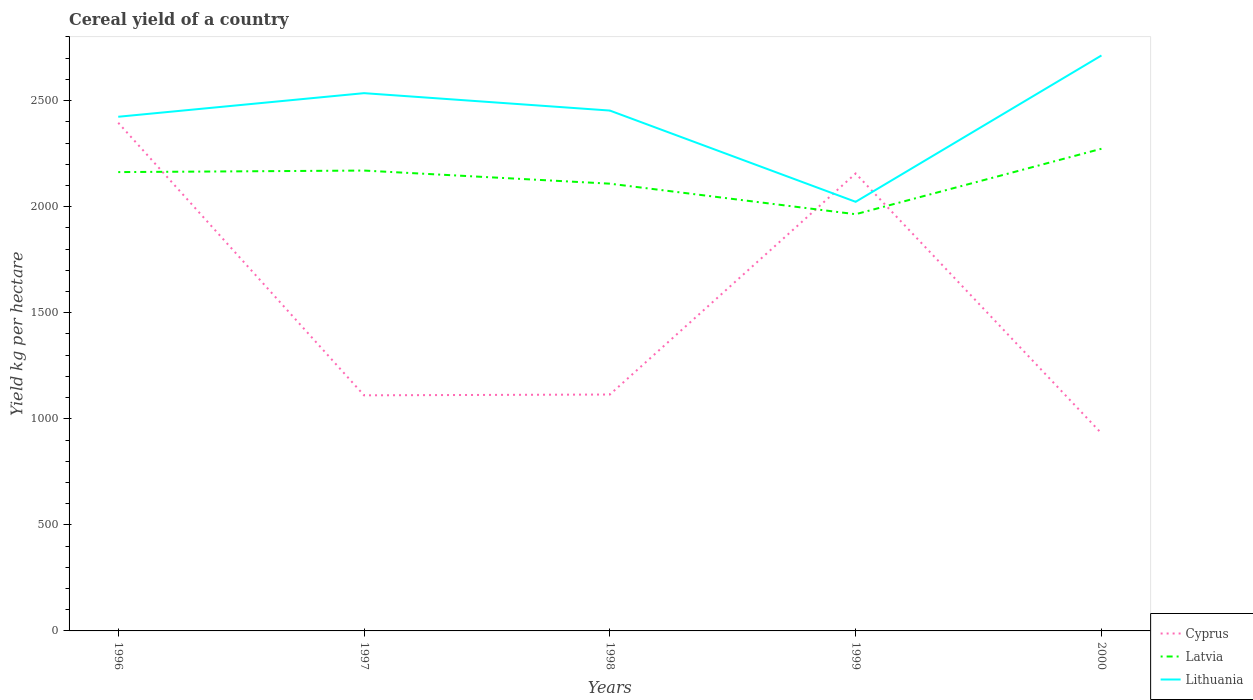Across all years, what is the maximum total cereal yield in Lithuania?
Provide a succinct answer. 2022.91. In which year was the total cereal yield in Lithuania maximum?
Provide a succinct answer. 1999. What is the total total cereal yield in Latvia in the graph?
Make the answer very short. 198.57. What is the difference between the highest and the second highest total cereal yield in Cyprus?
Offer a very short reply. 1464.06. What is the difference between the highest and the lowest total cereal yield in Cyprus?
Give a very brief answer. 2. Is the total cereal yield in Lithuania strictly greater than the total cereal yield in Cyprus over the years?
Provide a short and direct response. No. Does the graph contain grids?
Your response must be concise. No. How many legend labels are there?
Offer a very short reply. 3. What is the title of the graph?
Your response must be concise. Cereal yield of a country. Does "Hungary" appear as one of the legend labels in the graph?
Your answer should be compact. No. What is the label or title of the Y-axis?
Your answer should be compact. Yield kg per hectare. What is the Yield kg per hectare of Cyprus in 1996?
Your answer should be very brief. 2395.49. What is the Yield kg per hectare in Latvia in 1996?
Your answer should be very brief. 2162.99. What is the Yield kg per hectare of Lithuania in 1996?
Keep it short and to the point. 2423.86. What is the Yield kg per hectare in Cyprus in 1997?
Offer a terse response. 1110.65. What is the Yield kg per hectare in Latvia in 1997?
Keep it short and to the point. 2170.23. What is the Yield kg per hectare in Lithuania in 1997?
Make the answer very short. 2535.12. What is the Yield kg per hectare in Cyprus in 1998?
Ensure brevity in your answer.  1114.4. What is the Yield kg per hectare of Latvia in 1998?
Give a very brief answer. 2108.4. What is the Yield kg per hectare of Lithuania in 1998?
Give a very brief answer. 2453.09. What is the Yield kg per hectare in Cyprus in 1999?
Your response must be concise. 2156.43. What is the Yield kg per hectare in Latvia in 1999?
Provide a succinct answer. 1964.42. What is the Yield kg per hectare in Lithuania in 1999?
Make the answer very short. 2022.91. What is the Yield kg per hectare of Cyprus in 2000?
Your answer should be compact. 931.43. What is the Yield kg per hectare in Latvia in 2000?
Your response must be concise. 2273.05. What is the Yield kg per hectare in Lithuania in 2000?
Provide a succinct answer. 2712.78. Across all years, what is the maximum Yield kg per hectare in Cyprus?
Offer a very short reply. 2395.49. Across all years, what is the maximum Yield kg per hectare in Latvia?
Offer a very short reply. 2273.05. Across all years, what is the maximum Yield kg per hectare in Lithuania?
Your answer should be compact. 2712.78. Across all years, what is the minimum Yield kg per hectare in Cyprus?
Your answer should be compact. 931.43. Across all years, what is the minimum Yield kg per hectare in Latvia?
Your answer should be very brief. 1964.42. Across all years, what is the minimum Yield kg per hectare in Lithuania?
Provide a succinct answer. 2022.91. What is the total Yield kg per hectare in Cyprus in the graph?
Ensure brevity in your answer.  7708.4. What is the total Yield kg per hectare in Latvia in the graph?
Provide a short and direct response. 1.07e+04. What is the total Yield kg per hectare in Lithuania in the graph?
Your answer should be compact. 1.21e+04. What is the difference between the Yield kg per hectare of Cyprus in 1996 and that in 1997?
Offer a very short reply. 1284.84. What is the difference between the Yield kg per hectare in Latvia in 1996 and that in 1997?
Give a very brief answer. -7.24. What is the difference between the Yield kg per hectare of Lithuania in 1996 and that in 1997?
Offer a very short reply. -111.26. What is the difference between the Yield kg per hectare of Cyprus in 1996 and that in 1998?
Make the answer very short. 1281.09. What is the difference between the Yield kg per hectare of Latvia in 1996 and that in 1998?
Your answer should be very brief. 54.59. What is the difference between the Yield kg per hectare in Lithuania in 1996 and that in 1998?
Ensure brevity in your answer.  -29.23. What is the difference between the Yield kg per hectare in Cyprus in 1996 and that in 1999?
Ensure brevity in your answer.  239.06. What is the difference between the Yield kg per hectare in Latvia in 1996 and that in 1999?
Your answer should be compact. 198.57. What is the difference between the Yield kg per hectare of Lithuania in 1996 and that in 1999?
Your answer should be very brief. 400.95. What is the difference between the Yield kg per hectare of Cyprus in 1996 and that in 2000?
Offer a very short reply. 1464.06. What is the difference between the Yield kg per hectare in Latvia in 1996 and that in 2000?
Provide a short and direct response. -110.06. What is the difference between the Yield kg per hectare in Lithuania in 1996 and that in 2000?
Keep it short and to the point. -288.93. What is the difference between the Yield kg per hectare in Cyprus in 1997 and that in 1998?
Your response must be concise. -3.76. What is the difference between the Yield kg per hectare of Latvia in 1997 and that in 1998?
Offer a very short reply. 61.83. What is the difference between the Yield kg per hectare in Lithuania in 1997 and that in 1998?
Your response must be concise. 82.03. What is the difference between the Yield kg per hectare in Cyprus in 1997 and that in 1999?
Ensure brevity in your answer.  -1045.78. What is the difference between the Yield kg per hectare of Latvia in 1997 and that in 1999?
Offer a terse response. 205.81. What is the difference between the Yield kg per hectare of Lithuania in 1997 and that in 1999?
Provide a short and direct response. 512.21. What is the difference between the Yield kg per hectare of Cyprus in 1997 and that in 2000?
Your response must be concise. 179.22. What is the difference between the Yield kg per hectare in Latvia in 1997 and that in 2000?
Provide a succinct answer. -102.82. What is the difference between the Yield kg per hectare in Lithuania in 1997 and that in 2000?
Provide a succinct answer. -177.66. What is the difference between the Yield kg per hectare of Cyprus in 1998 and that in 1999?
Provide a short and direct response. -1042.03. What is the difference between the Yield kg per hectare of Latvia in 1998 and that in 1999?
Make the answer very short. 143.98. What is the difference between the Yield kg per hectare in Lithuania in 1998 and that in 1999?
Make the answer very short. 430.18. What is the difference between the Yield kg per hectare of Cyprus in 1998 and that in 2000?
Your answer should be compact. 182.97. What is the difference between the Yield kg per hectare of Latvia in 1998 and that in 2000?
Give a very brief answer. -164.65. What is the difference between the Yield kg per hectare of Lithuania in 1998 and that in 2000?
Offer a very short reply. -259.69. What is the difference between the Yield kg per hectare of Cyprus in 1999 and that in 2000?
Offer a very short reply. 1225. What is the difference between the Yield kg per hectare in Latvia in 1999 and that in 2000?
Provide a succinct answer. -308.63. What is the difference between the Yield kg per hectare of Lithuania in 1999 and that in 2000?
Your response must be concise. -689.87. What is the difference between the Yield kg per hectare of Cyprus in 1996 and the Yield kg per hectare of Latvia in 1997?
Your answer should be compact. 225.26. What is the difference between the Yield kg per hectare in Cyprus in 1996 and the Yield kg per hectare in Lithuania in 1997?
Make the answer very short. -139.63. What is the difference between the Yield kg per hectare of Latvia in 1996 and the Yield kg per hectare of Lithuania in 1997?
Offer a terse response. -372.13. What is the difference between the Yield kg per hectare of Cyprus in 1996 and the Yield kg per hectare of Latvia in 1998?
Keep it short and to the point. 287.09. What is the difference between the Yield kg per hectare in Cyprus in 1996 and the Yield kg per hectare in Lithuania in 1998?
Provide a short and direct response. -57.61. What is the difference between the Yield kg per hectare in Latvia in 1996 and the Yield kg per hectare in Lithuania in 1998?
Give a very brief answer. -290.1. What is the difference between the Yield kg per hectare in Cyprus in 1996 and the Yield kg per hectare in Latvia in 1999?
Keep it short and to the point. 431.07. What is the difference between the Yield kg per hectare in Cyprus in 1996 and the Yield kg per hectare in Lithuania in 1999?
Provide a succinct answer. 372.58. What is the difference between the Yield kg per hectare in Latvia in 1996 and the Yield kg per hectare in Lithuania in 1999?
Keep it short and to the point. 140.08. What is the difference between the Yield kg per hectare of Cyprus in 1996 and the Yield kg per hectare of Latvia in 2000?
Provide a succinct answer. 122.44. What is the difference between the Yield kg per hectare of Cyprus in 1996 and the Yield kg per hectare of Lithuania in 2000?
Ensure brevity in your answer.  -317.3. What is the difference between the Yield kg per hectare in Latvia in 1996 and the Yield kg per hectare in Lithuania in 2000?
Give a very brief answer. -549.79. What is the difference between the Yield kg per hectare of Cyprus in 1997 and the Yield kg per hectare of Latvia in 1998?
Offer a terse response. -997.75. What is the difference between the Yield kg per hectare of Cyprus in 1997 and the Yield kg per hectare of Lithuania in 1998?
Make the answer very short. -1342.45. What is the difference between the Yield kg per hectare in Latvia in 1997 and the Yield kg per hectare in Lithuania in 1998?
Keep it short and to the point. -282.86. What is the difference between the Yield kg per hectare in Cyprus in 1997 and the Yield kg per hectare in Latvia in 1999?
Make the answer very short. -853.77. What is the difference between the Yield kg per hectare in Cyprus in 1997 and the Yield kg per hectare in Lithuania in 1999?
Provide a succinct answer. -912.26. What is the difference between the Yield kg per hectare of Latvia in 1997 and the Yield kg per hectare of Lithuania in 1999?
Keep it short and to the point. 147.32. What is the difference between the Yield kg per hectare of Cyprus in 1997 and the Yield kg per hectare of Latvia in 2000?
Provide a short and direct response. -1162.4. What is the difference between the Yield kg per hectare of Cyprus in 1997 and the Yield kg per hectare of Lithuania in 2000?
Make the answer very short. -1602.14. What is the difference between the Yield kg per hectare of Latvia in 1997 and the Yield kg per hectare of Lithuania in 2000?
Offer a terse response. -542.55. What is the difference between the Yield kg per hectare in Cyprus in 1998 and the Yield kg per hectare in Latvia in 1999?
Ensure brevity in your answer.  -850.02. What is the difference between the Yield kg per hectare of Cyprus in 1998 and the Yield kg per hectare of Lithuania in 1999?
Your answer should be compact. -908.51. What is the difference between the Yield kg per hectare of Latvia in 1998 and the Yield kg per hectare of Lithuania in 1999?
Make the answer very short. 85.49. What is the difference between the Yield kg per hectare of Cyprus in 1998 and the Yield kg per hectare of Latvia in 2000?
Your response must be concise. -1158.65. What is the difference between the Yield kg per hectare of Cyprus in 1998 and the Yield kg per hectare of Lithuania in 2000?
Provide a succinct answer. -1598.38. What is the difference between the Yield kg per hectare in Latvia in 1998 and the Yield kg per hectare in Lithuania in 2000?
Offer a terse response. -604.38. What is the difference between the Yield kg per hectare in Cyprus in 1999 and the Yield kg per hectare in Latvia in 2000?
Provide a succinct answer. -116.62. What is the difference between the Yield kg per hectare of Cyprus in 1999 and the Yield kg per hectare of Lithuania in 2000?
Offer a very short reply. -556.35. What is the difference between the Yield kg per hectare in Latvia in 1999 and the Yield kg per hectare in Lithuania in 2000?
Your answer should be compact. -748.36. What is the average Yield kg per hectare of Cyprus per year?
Your answer should be compact. 1541.68. What is the average Yield kg per hectare of Latvia per year?
Make the answer very short. 2135.82. What is the average Yield kg per hectare of Lithuania per year?
Provide a succinct answer. 2429.55. In the year 1996, what is the difference between the Yield kg per hectare in Cyprus and Yield kg per hectare in Latvia?
Give a very brief answer. 232.5. In the year 1996, what is the difference between the Yield kg per hectare in Cyprus and Yield kg per hectare in Lithuania?
Keep it short and to the point. -28.37. In the year 1996, what is the difference between the Yield kg per hectare in Latvia and Yield kg per hectare in Lithuania?
Provide a succinct answer. -260.87. In the year 1997, what is the difference between the Yield kg per hectare of Cyprus and Yield kg per hectare of Latvia?
Your response must be concise. -1059.59. In the year 1997, what is the difference between the Yield kg per hectare in Cyprus and Yield kg per hectare in Lithuania?
Your answer should be very brief. -1424.47. In the year 1997, what is the difference between the Yield kg per hectare in Latvia and Yield kg per hectare in Lithuania?
Your answer should be very brief. -364.89. In the year 1998, what is the difference between the Yield kg per hectare in Cyprus and Yield kg per hectare in Latvia?
Keep it short and to the point. -994. In the year 1998, what is the difference between the Yield kg per hectare in Cyprus and Yield kg per hectare in Lithuania?
Your answer should be very brief. -1338.69. In the year 1998, what is the difference between the Yield kg per hectare of Latvia and Yield kg per hectare of Lithuania?
Your answer should be compact. -344.69. In the year 1999, what is the difference between the Yield kg per hectare of Cyprus and Yield kg per hectare of Latvia?
Provide a succinct answer. 192.01. In the year 1999, what is the difference between the Yield kg per hectare of Cyprus and Yield kg per hectare of Lithuania?
Offer a very short reply. 133.52. In the year 1999, what is the difference between the Yield kg per hectare of Latvia and Yield kg per hectare of Lithuania?
Your answer should be compact. -58.49. In the year 2000, what is the difference between the Yield kg per hectare of Cyprus and Yield kg per hectare of Latvia?
Give a very brief answer. -1341.62. In the year 2000, what is the difference between the Yield kg per hectare in Cyprus and Yield kg per hectare in Lithuania?
Your answer should be very brief. -1781.35. In the year 2000, what is the difference between the Yield kg per hectare of Latvia and Yield kg per hectare of Lithuania?
Make the answer very short. -439.73. What is the ratio of the Yield kg per hectare of Cyprus in 1996 to that in 1997?
Offer a terse response. 2.16. What is the ratio of the Yield kg per hectare in Latvia in 1996 to that in 1997?
Your answer should be compact. 1. What is the ratio of the Yield kg per hectare of Lithuania in 1996 to that in 1997?
Your answer should be very brief. 0.96. What is the ratio of the Yield kg per hectare in Cyprus in 1996 to that in 1998?
Offer a very short reply. 2.15. What is the ratio of the Yield kg per hectare in Latvia in 1996 to that in 1998?
Your response must be concise. 1.03. What is the ratio of the Yield kg per hectare in Cyprus in 1996 to that in 1999?
Your answer should be compact. 1.11. What is the ratio of the Yield kg per hectare of Latvia in 1996 to that in 1999?
Ensure brevity in your answer.  1.1. What is the ratio of the Yield kg per hectare of Lithuania in 1996 to that in 1999?
Your response must be concise. 1.2. What is the ratio of the Yield kg per hectare in Cyprus in 1996 to that in 2000?
Your answer should be very brief. 2.57. What is the ratio of the Yield kg per hectare of Latvia in 1996 to that in 2000?
Make the answer very short. 0.95. What is the ratio of the Yield kg per hectare of Lithuania in 1996 to that in 2000?
Give a very brief answer. 0.89. What is the ratio of the Yield kg per hectare of Latvia in 1997 to that in 1998?
Your answer should be very brief. 1.03. What is the ratio of the Yield kg per hectare in Lithuania in 1997 to that in 1998?
Your response must be concise. 1.03. What is the ratio of the Yield kg per hectare of Cyprus in 1997 to that in 1999?
Offer a terse response. 0.52. What is the ratio of the Yield kg per hectare in Latvia in 1997 to that in 1999?
Offer a terse response. 1.1. What is the ratio of the Yield kg per hectare in Lithuania in 1997 to that in 1999?
Provide a succinct answer. 1.25. What is the ratio of the Yield kg per hectare in Cyprus in 1997 to that in 2000?
Keep it short and to the point. 1.19. What is the ratio of the Yield kg per hectare in Latvia in 1997 to that in 2000?
Your answer should be compact. 0.95. What is the ratio of the Yield kg per hectare in Lithuania in 1997 to that in 2000?
Offer a terse response. 0.93. What is the ratio of the Yield kg per hectare of Cyprus in 1998 to that in 1999?
Give a very brief answer. 0.52. What is the ratio of the Yield kg per hectare of Latvia in 1998 to that in 1999?
Offer a very short reply. 1.07. What is the ratio of the Yield kg per hectare of Lithuania in 1998 to that in 1999?
Provide a short and direct response. 1.21. What is the ratio of the Yield kg per hectare of Cyprus in 1998 to that in 2000?
Offer a very short reply. 1.2. What is the ratio of the Yield kg per hectare in Latvia in 1998 to that in 2000?
Offer a terse response. 0.93. What is the ratio of the Yield kg per hectare of Lithuania in 1998 to that in 2000?
Your answer should be very brief. 0.9. What is the ratio of the Yield kg per hectare in Cyprus in 1999 to that in 2000?
Offer a terse response. 2.32. What is the ratio of the Yield kg per hectare of Latvia in 1999 to that in 2000?
Make the answer very short. 0.86. What is the ratio of the Yield kg per hectare of Lithuania in 1999 to that in 2000?
Offer a terse response. 0.75. What is the difference between the highest and the second highest Yield kg per hectare in Cyprus?
Offer a terse response. 239.06. What is the difference between the highest and the second highest Yield kg per hectare in Latvia?
Ensure brevity in your answer.  102.82. What is the difference between the highest and the second highest Yield kg per hectare of Lithuania?
Your answer should be compact. 177.66. What is the difference between the highest and the lowest Yield kg per hectare of Cyprus?
Offer a very short reply. 1464.06. What is the difference between the highest and the lowest Yield kg per hectare in Latvia?
Your response must be concise. 308.63. What is the difference between the highest and the lowest Yield kg per hectare in Lithuania?
Your answer should be very brief. 689.87. 